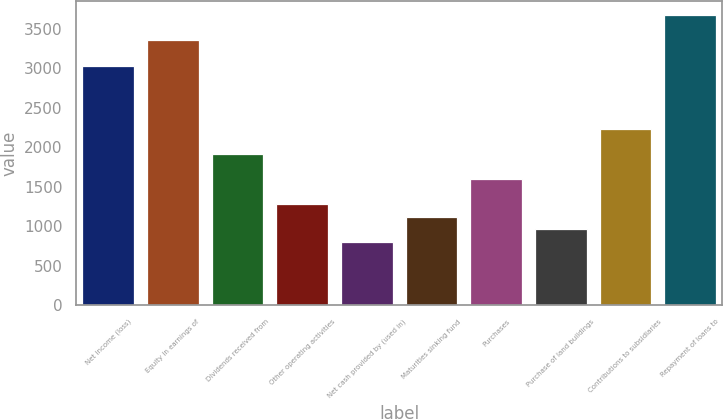Convert chart to OTSL. <chart><loc_0><loc_0><loc_500><loc_500><bar_chart><fcel>Net income (loss)<fcel>Equity in earnings of<fcel>Dividends received from<fcel>Other operating activities<fcel>Net cash provided by (used in)<fcel>Maturities sinking fund<fcel>Purchases<fcel>Purchase of land buildings<fcel>Contributions to subsidiaries<fcel>Repayment of loans to<nl><fcel>3034.5<fcel>3353.5<fcel>1918<fcel>1280<fcel>801.5<fcel>1120.5<fcel>1599<fcel>961<fcel>2237<fcel>3672.5<nl></chart> 